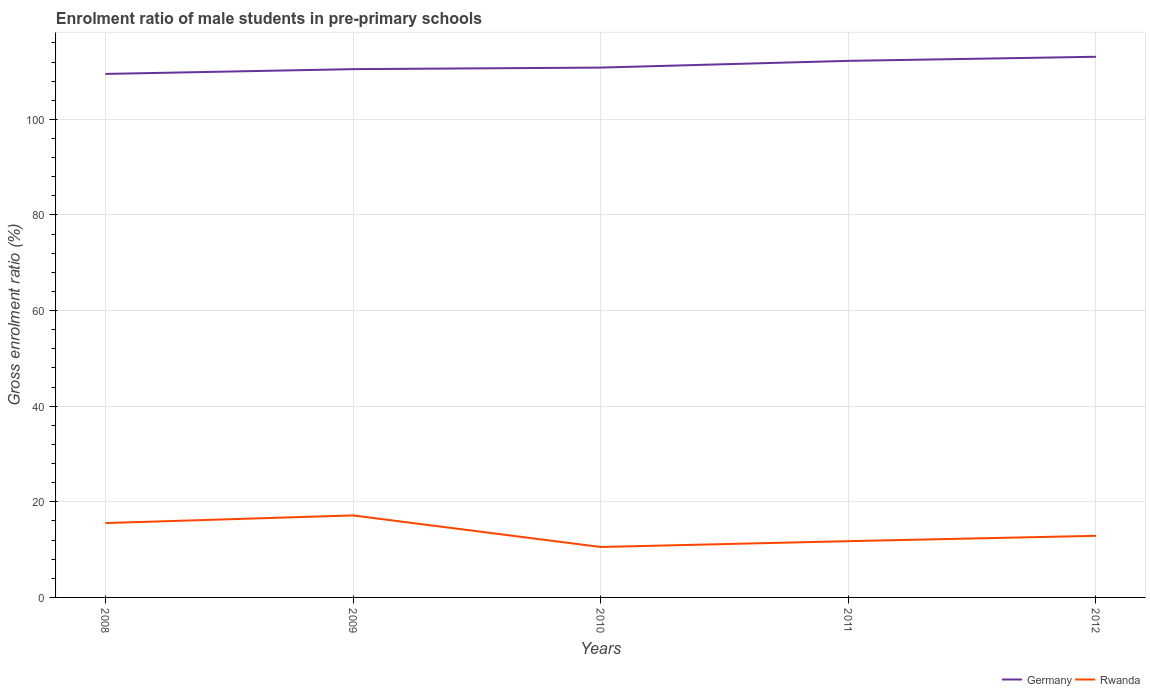Does the line corresponding to Rwanda intersect with the line corresponding to Germany?
Make the answer very short. No. Is the number of lines equal to the number of legend labels?
Give a very brief answer. Yes. Across all years, what is the maximum enrolment ratio of male students in pre-primary schools in Germany?
Ensure brevity in your answer.  109.51. In which year was the enrolment ratio of male students in pre-primary schools in Rwanda maximum?
Offer a terse response. 2010. What is the total enrolment ratio of male students in pre-primary schools in Rwanda in the graph?
Your answer should be compact. -1.12. What is the difference between the highest and the second highest enrolment ratio of male students in pre-primary schools in Rwanda?
Provide a succinct answer. 6.6. What is the difference between the highest and the lowest enrolment ratio of male students in pre-primary schools in Germany?
Provide a short and direct response. 2. Is the enrolment ratio of male students in pre-primary schools in Rwanda strictly greater than the enrolment ratio of male students in pre-primary schools in Germany over the years?
Offer a very short reply. Yes. What is the difference between two consecutive major ticks on the Y-axis?
Offer a terse response. 20. How many legend labels are there?
Offer a very short reply. 2. How are the legend labels stacked?
Your answer should be compact. Horizontal. What is the title of the graph?
Provide a succinct answer. Enrolment ratio of male students in pre-primary schools. Does "Bangladesh" appear as one of the legend labels in the graph?
Your answer should be compact. No. What is the label or title of the Y-axis?
Make the answer very short. Gross enrolment ratio (%). What is the Gross enrolment ratio (%) in Germany in 2008?
Offer a terse response. 109.51. What is the Gross enrolment ratio (%) of Rwanda in 2008?
Give a very brief answer. 15.55. What is the Gross enrolment ratio (%) of Germany in 2009?
Offer a terse response. 110.51. What is the Gross enrolment ratio (%) of Rwanda in 2009?
Make the answer very short. 17.15. What is the Gross enrolment ratio (%) of Germany in 2010?
Keep it short and to the point. 110.83. What is the Gross enrolment ratio (%) in Rwanda in 2010?
Provide a short and direct response. 10.55. What is the Gross enrolment ratio (%) of Germany in 2011?
Offer a terse response. 112.24. What is the Gross enrolment ratio (%) of Rwanda in 2011?
Your answer should be compact. 11.77. What is the Gross enrolment ratio (%) in Germany in 2012?
Provide a succinct answer. 113.1. What is the Gross enrolment ratio (%) of Rwanda in 2012?
Make the answer very short. 12.89. Across all years, what is the maximum Gross enrolment ratio (%) in Germany?
Offer a very short reply. 113.1. Across all years, what is the maximum Gross enrolment ratio (%) of Rwanda?
Keep it short and to the point. 17.15. Across all years, what is the minimum Gross enrolment ratio (%) of Germany?
Provide a short and direct response. 109.51. Across all years, what is the minimum Gross enrolment ratio (%) of Rwanda?
Ensure brevity in your answer.  10.55. What is the total Gross enrolment ratio (%) in Germany in the graph?
Offer a terse response. 556.19. What is the total Gross enrolment ratio (%) in Rwanda in the graph?
Ensure brevity in your answer.  67.92. What is the difference between the Gross enrolment ratio (%) in Germany in 2008 and that in 2009?
Offer a terse response. -1. What is the difference between the Gross enrolment ratio (%) in Rwanda in 2008 and that in 2009?
Your answer should be very brief. -1.6. What is the difference between the Gross enrolment ratio (%) in Germany in 2008 and that in 2010?
Offer a terse response. -1.33. What is the difference between the Gross enrolment ratio (%) of Rwanda in 2008 and that in 2010?
Your answer should be very brief. 5. What is the difference between the Gross enrolment ratio (%) of Germany in 2008 and that in 2011?
Provide a succinct answer. -2.73. What is the difference between the Gross enrolment ratio (%) in Rwanda in 2008 and that in 2011?
Make the answer very short. 3.78. What is the difference between the Gross enrolment ratio (%) of Germany in 2008 and that in 2012?
Make the answer very short. -3.59. What is the difference between the Gross enrolment ratio (%) in Rwanda in 2008 and that in 2012?
Your response must be concise. 2.67. What is the difference between the Gross enrolment ratio (%) of Germany in 2009 and that in 2010?
Provide a succinct answer. -0.32. What is the difference between the Gross enrolment ratio (%) in Rwanda in 2009 and that in 2010?
Make the answer very short. 6.6. What is the difference between the Gross enrolment ratio (%) of Germany in 2009 and that in 2011?
Offer a terse response. -1.73. What is the difference between the Gross enrolment ratio (%) of Rwanda in 2009 and that in 2011?
Your answer should be compact. 5.38. What is the difference between the Gross enrolment ratio (%) of Germany in 2009 and that in 2012?
Give a very brief answer. -2.59. What is the difference between the Gross enrolment ratio (%) of Rwanda in 2009 and that in 2012?
Offer a very short reply. 4.26. What is the difference between the Gross enrolment ratio (%) in Germany in 2010 and that in 2011?
Keep it short and to the point. -1.41. What is the difference between the Gross enrolment ratio (%) in Rwanda in 2010 and that in 2011?
Your answer should be very brief. -1.22. What is the difference between the Gross enrolment ratio (%) in Germany in 2010 and that in 2012?
Make the answer very short. -2.26. What is the difference between the Gross enrolment ratio (%) in Rwanda in 2010 and that in 2012?
Give a very brief answer. -2.34. What is the difference between the Gross enrolment ratio (%) in Germany in 2011 and that in 2012?
Provide a short and direct response. -0.86. What is the difference between the Gross enrolment ratio (%) in Rwanda in 2011 and that in 2012?
Your answer should be very brief. -1.12. What is the difference between the Gross enrolment ratio (%) in Germany in 2008 and the Gross enrolment ratio (%) in Rwanda in 2009?
Provide a succinct answer. 92.36. What is the difference between the Gross enrolment ratio (%) of Germany in 2008 and the Gross enrolment ratio (%) of Rwanda in 2010?
Make the answer very short. 98.96. What is the difference between the Gross enrolment ratio (%) of Germany in 2008 and the Gross enrolment ratio (%) of Rwanda in 2011?
Keep it short and to the point. 97.74. What is the difference between the Gross enrolment ratio (%) of Germany in 2008 and the Gross enrolment ratio (%) of Rwanda in 2012?
Offer a very short reply. 96.62. What is the difference between the Gross enrolment ratio (%) in Germany in 2009 and the Gross enrolment ratio (%) in Rwanda in 2010?
Make the answer very short. 99.96. What is the difference between the Gross enrolment ratio (%) in Germany in 2009 and the Gross enrolment ratio (%) in Rwanda in 2011?
Offer a terse response. 98.74. What is the difference between the Gross enrolment ratio (%) in Germany in 2009 and the Gross enrolment ratio (%) in Rwanda in 2012?
Ensure brevity in your answer.  97.62. What is the difference between the Gross enrolment ratio (%) in Germany in 2010 and the Gross enrolment ratio (%) in Rwanda in 2011?
Ensure brevity in your answer.  99.06. What is the difference between the Gross enrolment ratio (%) in Germany in 2010 and the Gross enrolment ratio (%) in Rwanda in 2012?
Give a very brief answer. 97.94. What is the difference between the Gross enrolment ratio (%) of Germany in 2011 and the Gross enrolment ratio (%) of Rwanda in 2012?
Give a very brief answer. 99.35. What is the average Gross enrolment ratio (%) of Germany per year?
Provide a succinct answer. 111.24. What is the average Gross enrolment ratio (%) in Rwanda per year?
Keep it short and to the point. 13.58. In the year 2008, what is the difference between the Gross enrolment ratio (%) in Germany and Gross enrolment ratio (%) in Rwanda?
Provide a succinct answer. 93.95. In the year 2009, what is the difference between the Gross enrolment ratio (%) of Germany and Gross enrolment ratio (%) of Rwanda?
Offer a terse response. 93.36. In the year 2010, what is the difference between the Gross enrolment ratio (%) in Germany and Gross enrolment ratio (%) in Rwanda?
Your answer should be very brief. 100.28. In the year 2011, what is the difference between the Gross enrolment ratio (%) in Germany and Gross enrolment ratio (%) in Rwanda?
Provide a short and direct response. 100.47. In the year 2012, what is the difference between the Gross enrolment ratio (%) in Germany and Gross enrolment ratio (%) in Rwanda?
Ensure brevity in your answer.  100.21. What is the ratio of the Gross enrolment ratio (%) in Germany in 2008 to that in 2009?
Keep it short and to the point. 0.99. What is the ratio of the Gross enrolment ratio (%) of Rwanda in 2008 to that in 2009?
Give a very brief answer. 0.91. What is the ratio of the Gross enrolment ratio (%) of Germany in 2008 to that in 2010?
Provide a short and direct response. 0.99. What is the ratio of the Gross enrolment ratio (%) of Rwanda in 2008 to that in 2010?
Your response must be concise. 1.47. What is the ratio of the Gross enrolment ratio (%) in Germany in 2008 to that in 2011?
Make the answer very short. 0.98. What is the ratio of the Gross enrolment ratio (%) of Rwanda in 2008 to that in 2011?
Your response must be concise. 1.32. What is the ratio of the Gross enrolment ratio (%) in Germany in 2008 to that in 2012?
Your answer should be compact. 0.97. What is the ratio of the Gross enrolment ratio (%) in Rwanda in 2008 to that in 2012?
Offer a very short reply. 1.21. What is the ratio of the Gross enrolment ratio (%) of Germany in 2009 to that in 2010?
Your answer should be compact. 1. What is the ratio of the Gross enrolment ratio (%) in Rwanda in 2009 to that in 2010?
Provide a succinct answer. 1.63. What is the ratio of the Gross enrolment ratio (%) of Germany in 2009 to that in 2011?
Your answer should be very brief. 0.98. What is the ratio of the Gross enrolment ratio (%) in Rwanda in 2009 to that in 2011?
Provide a short and direct response. 1.46. What is the ratio of the Gross enrolment ratio (%) of Germany in 2009 to that in 2012?
Your answer should be very brief. 0.98. What is the ratio of the Gross enrolment ratio (%) of Rwanda in 2009 to that in 2012?
Your answer should be compact. 1.33. What is the ratio of the Gross enrolment ratio (%) in Germany in 2010 to that in 2011?
Offer a very short reply. 0.99. What is the ratio of the Gross enrolment ratio (%) in Rwanda in 2010 to that in 2011?
Offer a terse response. 0.9. What is the ratio of the Gross enrolment ratio (%) in Rwanda in 2010 to that in 2012?
Make the answer very short. 0.82. What is the ratio of the Gross enrolment ratio (%) of Rwanda in 2011 to that in 2012?
Your response must be concise. 0.91. What is the difference between the highest and the second highest Gross enrolment ratio (%) of Germany?
Your answer should be very brief. 0.86. What is the difference between the highest and the second highest Gross enrolment ratio (%) of Rwanda?
Give a very brief answer. 1.6. What is the difference between the highest and the lowest Gross enrolment ratio (%) in Germany?
Provide a succinct answer. 3.59. What is the difference between the highest and the lowest Gross enrolment ratio (%) in Rwanda?
Your answer should be very brief. 6.6. 